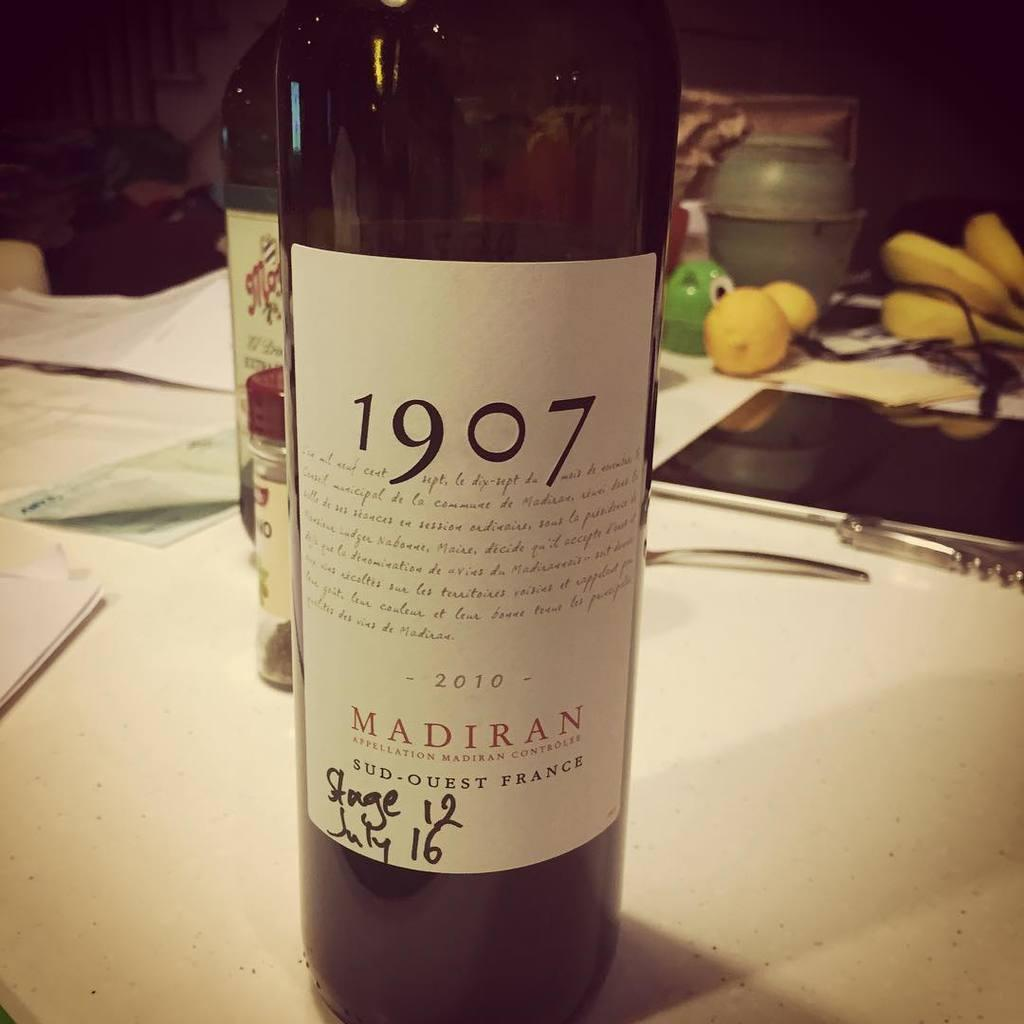<image>
Present a compact description of the photo's key features. A bottle of wine with the logo 1907 from France is on a table. 